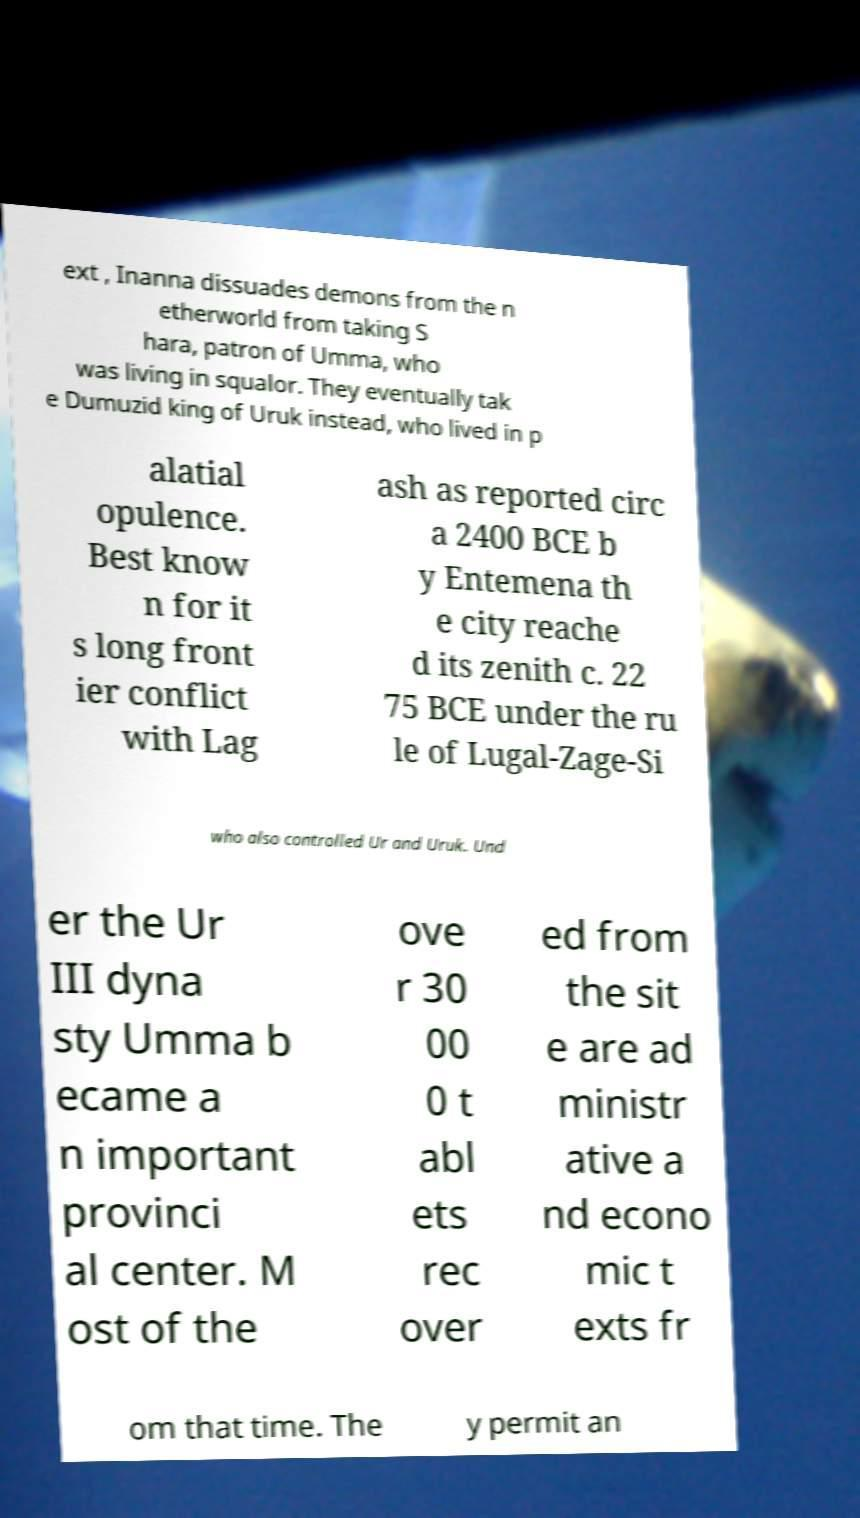Can you read and provide the text displayed in the image?This photo seems to have some interesting text. Can you extract and type it out for me? ext , Inanna dissuades demons from the n etherworld from taking S hara, patron of Umma, who was living in squalor. They eventually tak e Dumuzid king of Uruk instead, who lived in p alatial opulence. Best know n for it s long front ier conflict with Lag ash as reported circ a 2400 BCE b y Entemena th e city reache d its zenith c. 22 75 BCE under the ru le of Lugal-Zage-Si who also controlled Ur and Uruk. Und er the Ur III dyna sty Umma b ecame a n important provinci al center. M ost of the ove r 30 00 0 t abl ets rec over ed from the sit e are ad ministr ative a nd econo mic t exts fr om that time. The y permit an 